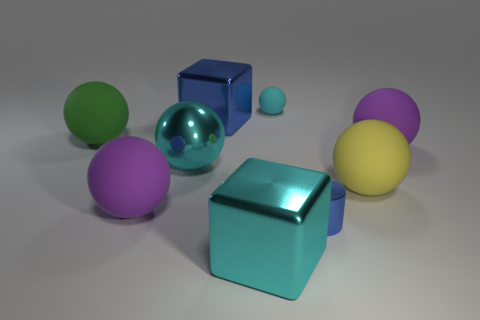Subtract 1 spheres. How many spheres are left? 5 Subtract all large cyan shiny balls. How many balls are left? 5 Subtract all green balls. How many balls are left? 5 Subtract all gray cylinders. Subtract all purple spheres. How many cylinders are left? 1 Subtract all cylinders. How many objects are left? 8 Subtract all tiny blue things. Subtract all big blue objects. How many objects are left? 7 Add 3 large metallic things. How many large metallic things are left? 6 Add 4 large blue shiny objects. How many large blue shiny objects exist? 5 Subtract 0 blue spheres. How many objects are left? 9 